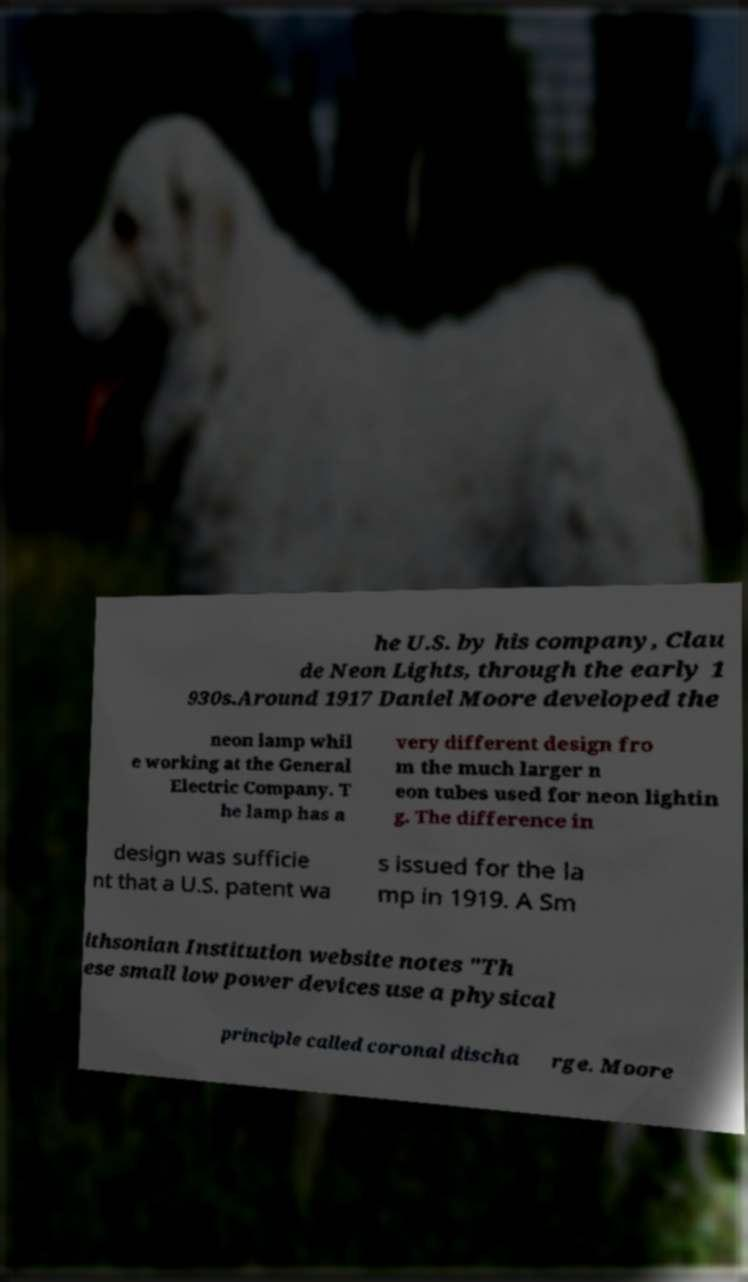There's text embedded in this image that I need extracted. Can you transcribe it verbatim? he U.S. by his company, Clau de Neon Lights, through the early 1 930s.Around 1917 Daniel Moore developed the neon lamp whil e working at the General Electric Company. T he lamp has a very different design fro m the much larger n eon tubes used for neon lightin g. The difference in design was sufficie nt that a U.S. patent wa s issued for the la mp in 1919. A Sm ithsonian Institution website notes "Th ese small low power devices use a physical principle called coronal discha rge. Moore 